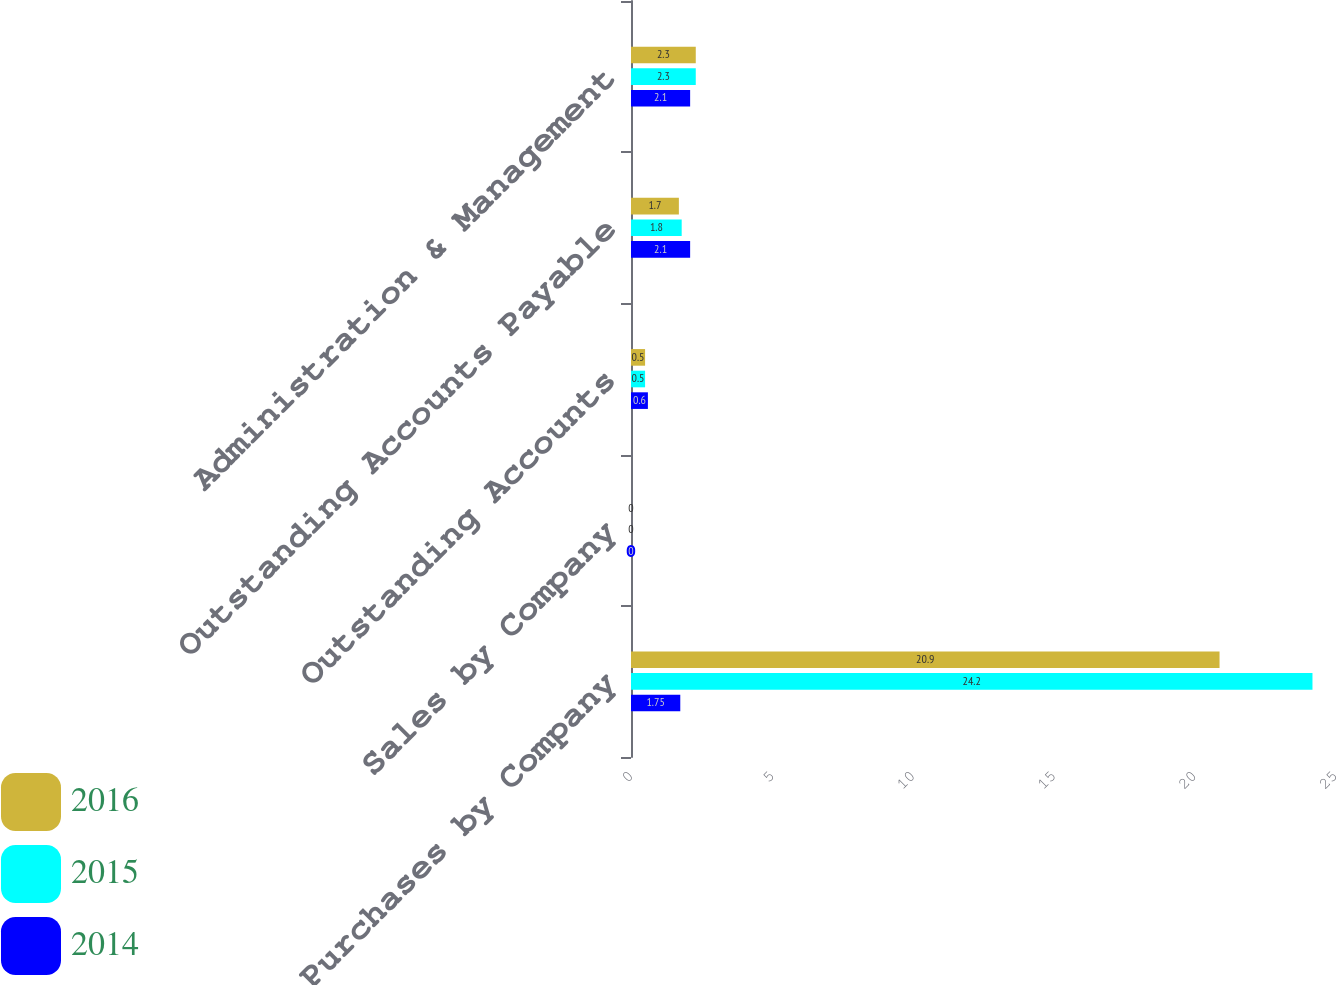Convert chart to OTSL. <chart><loc_0><loc_0><loc_500><loc_500><stacked_bar_chart><ecel><fcel>Purchases by Company<fcel>Sales by Company<fcel>Outstanding Accounts<fcel>Outstanding Accounts Payable<fcel>Administration & Management<nl><fcel>2016<fcel>20.9<fcel>0<fcel>0.5<fcel>1.7<fcel>2.3<nl><fcel>2015<fcel>24.2<fcel>0<fcel>0.5<fcel>1.8<fcel>2.3<nl><fcel>2014<fcel>1.75<fcel>0<fcel>0.6<fcel>2.1<fcel>2.1<nl></chart> 